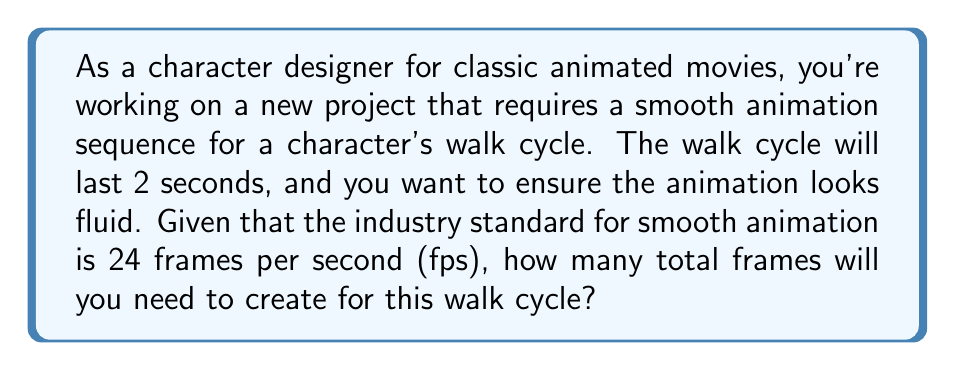Give your solution to this math problem. To solve this problem, we need to use a linear equation that relates the number of frames to the duration of the animation and the frame rate. Let's break it down step-by-step:

1. Identify the given information:
   - Duration of the walk cycle: 2 seconds
   - Frame rate for smooth animation: 24 frames per second (fps)

2. Set up the linear equation:
   Let $x$ be the total number of frames needed.
   
   $$ x = \text{frame rate} \times \text{duration} $$

3. Substitute the known values into the equation:
   $$ x = 24 \text{ fps} \times 2 \text{ seconds} $$

4. Solve the equation:
   $$ x = 48 \text{ frames} $$

This calculation shows that to create a smooth 2-second walk cycle at 24 fps, you'll need to design 48 individual frames.

In animation, this concept is often referred to as "on twos" or "on ones". Animation "on twos" means creating a new drawing every two frames, which results in 12 unique drawings per second. Animation "on ones" means creating a new drawing for every frame, resulting in 24 unique drawings per second. The latter produces smoother animation but requires more work.

For this walk cycle, you could choose to animate "on ones" (48 unique drawings) for maximum smoothness, or "on twos" (24 unique drawings) which still provides good quality while reducing the workload.
Answer: 48 frames 